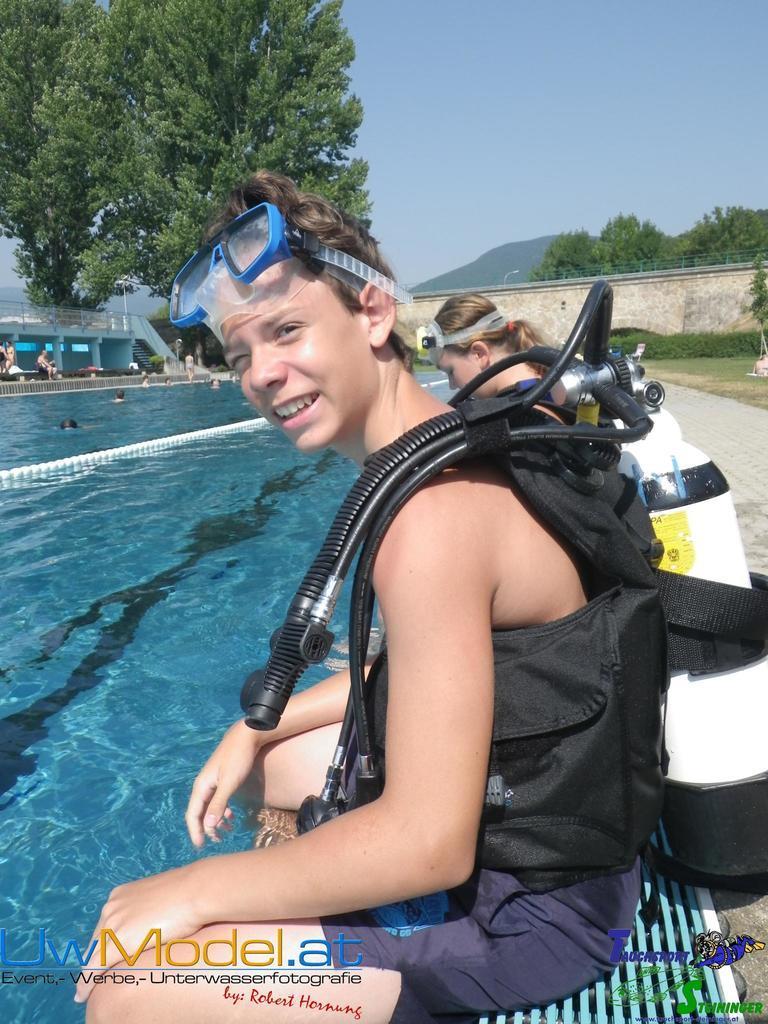Please provide a concise description of this image. In this picture there are two people sitting. On the left side of the image there are group of people in the water and there is a building. At the back there are trees and there is a mountain and there is a street light and there is a railing on the wall. At the top there is sky. At the bottom there is a pavement and there is grass. At the bottom left there is text and at the bottom right there is text. 